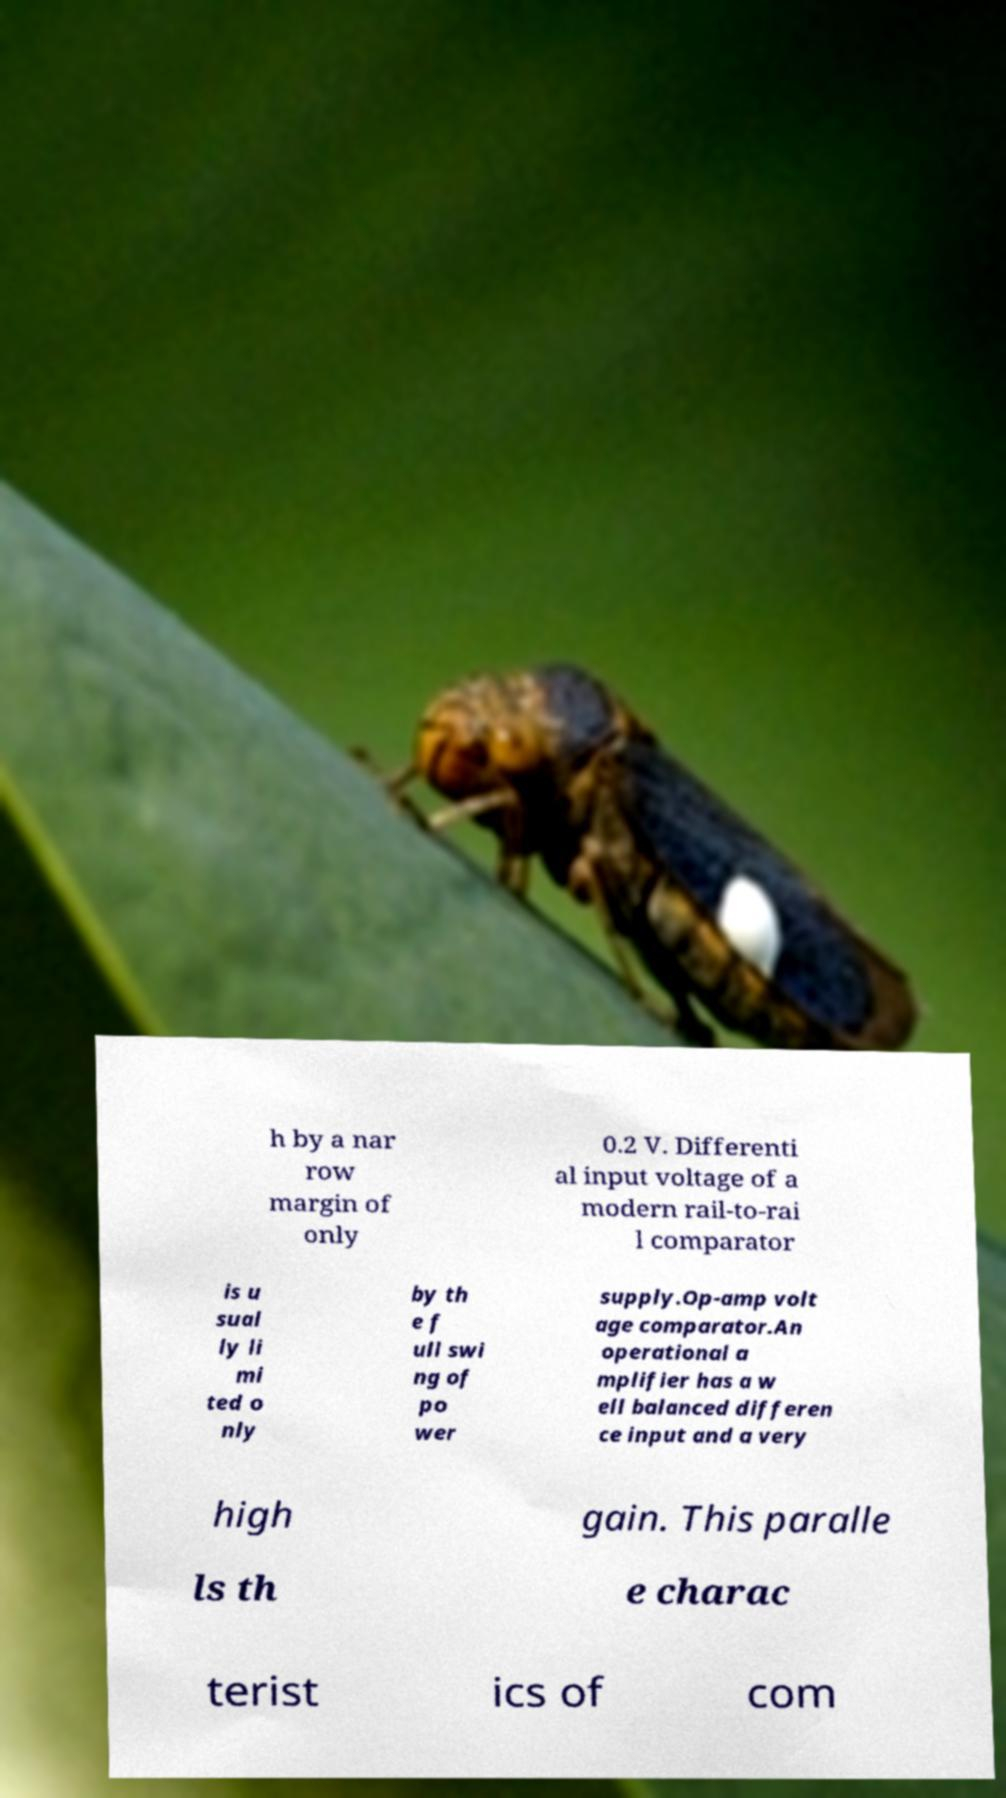Can you accurately transcribe the text from the provided image for me? h by a nar row margin of only 0.2 V. Differenti al input voltage of a modern rail-to-rai l comparator is u sual ly li mi ted o nly by th e f ull swi ng of po wer supply.Op-amp volt age comparator.An operational a mplifier has a w ell balanced differen ce input and a very high gain. This paralle ls th e charac terist ics of com 